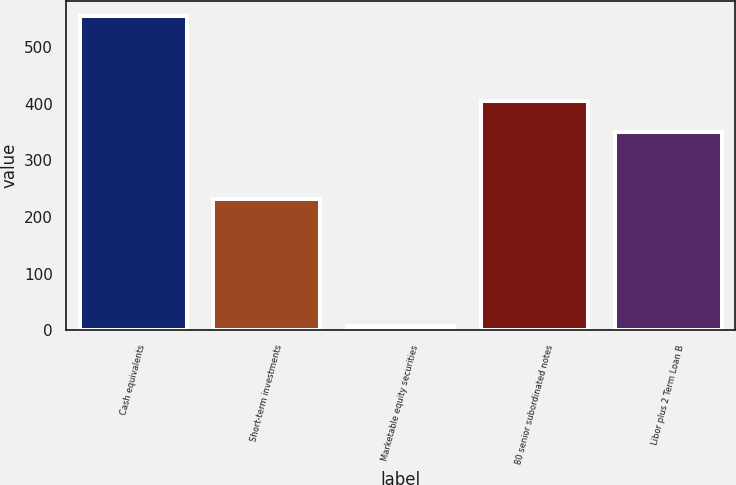Convert chart to OTSL. <chart><loc_0><loc_0><loc_500><loc_500><bar_chart><fcel>Cash equivalents<fcel>Short-term investments<fcel>Marketable equity securities<fcel>80 senior subordinated notes<fcel>Libor plus 2 Term Loan B<nl><fcel>554<fcel>231<fcel>7<fcel>404.7<fcel>350<nl></chart> 